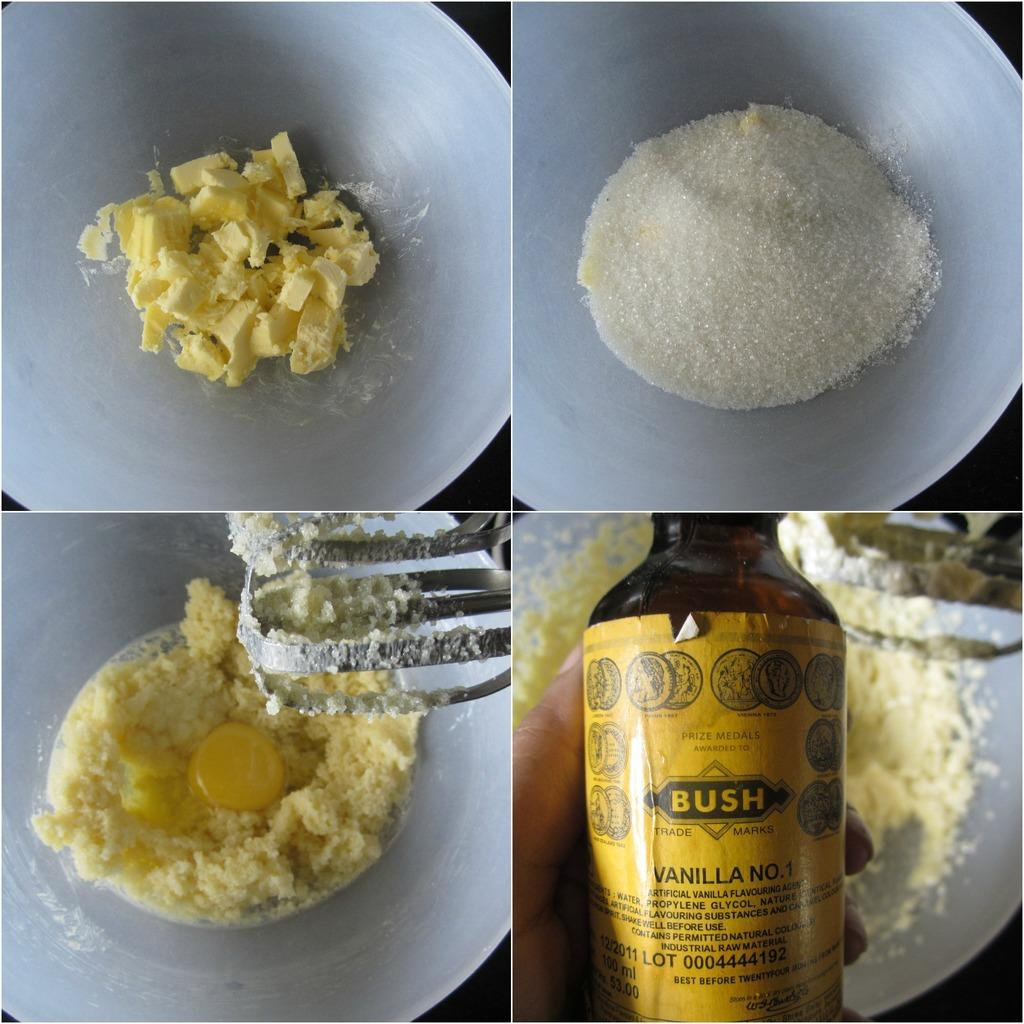<image>
Share a concise interpretation of the image provided. Collage of images including a person holding a BUSH bottle on the lower right. 